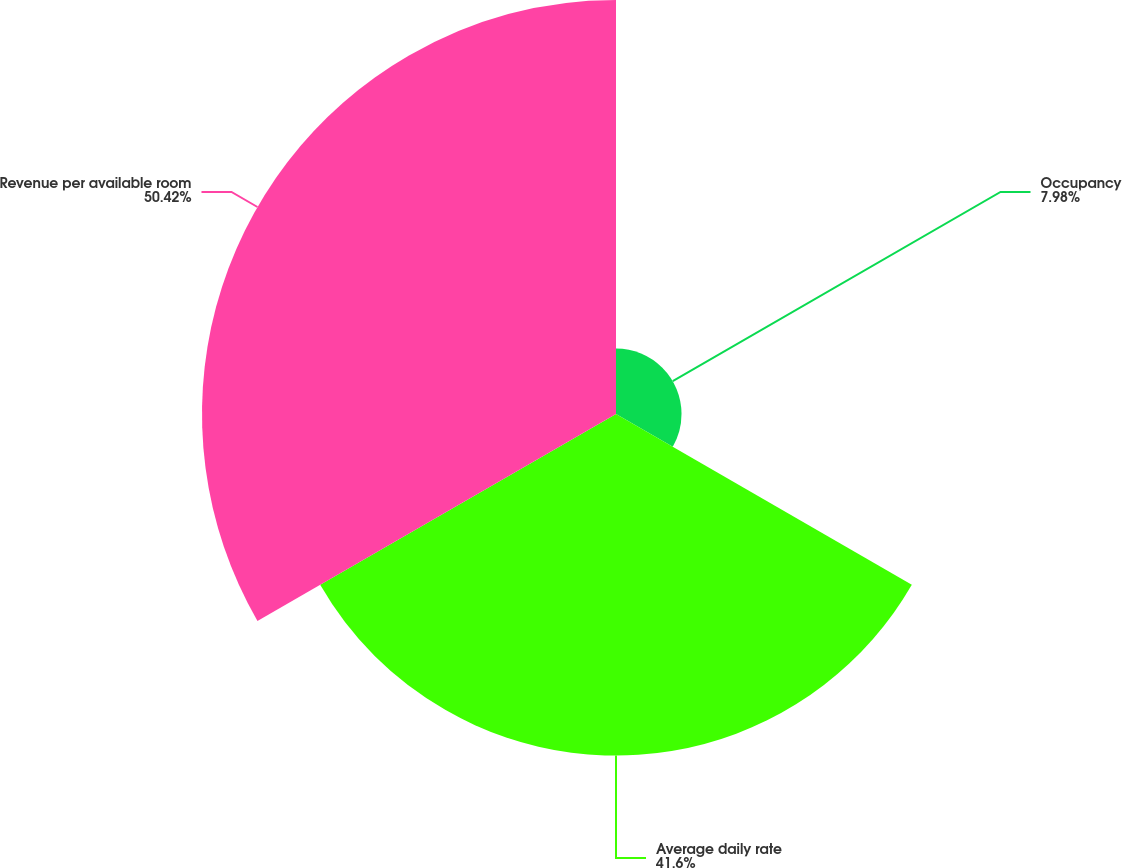Convert chart. <chart><loc_0><loc_0><loc_500><loc_500><pie_chart><fcel>Occupancy<fcel>Average daily rate<fcel>Revenue per available room<nl><fcel>7.98%<fcel>41.6%<fcel>50.42%<nl></chart> 